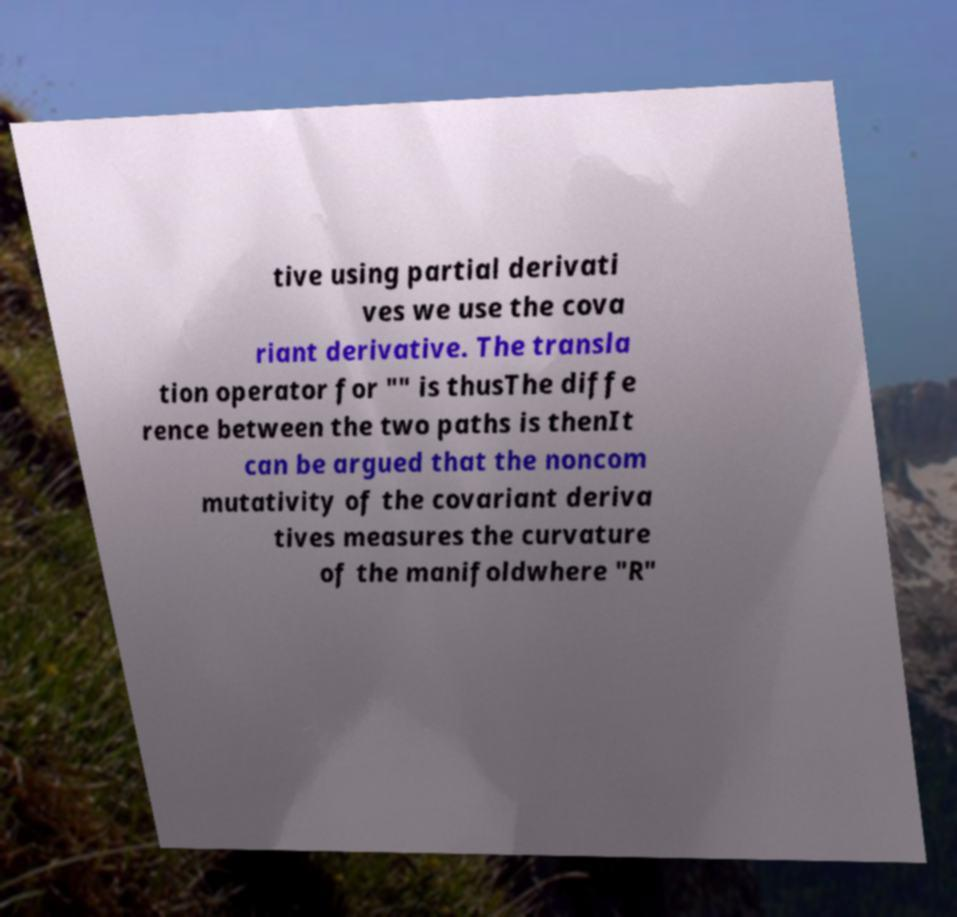I need the written content from this picture converted into text. Can you do that? tive using partial derivati ves we use the cova riant derivative. The transla tion operator for "" is thusThe diffe rence between the two paths is thenIt can be argued that the noncom mutativity of the covariant deriva tives measures the curvature of the manifoldwhere "R" 